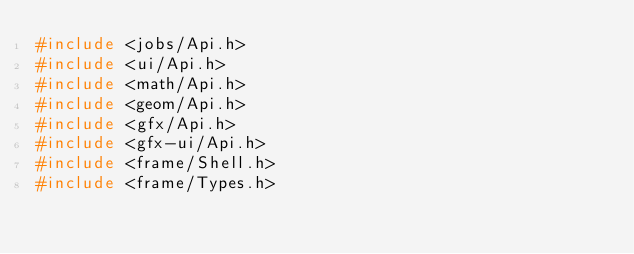<code> <loc_0><loc_0><loc_500><loc_500><_C_>#include <jobs/Api.h>
#include <ui/Api.h>
#include <math/Api.h>
#include <geom/Api.h>
#include <gfx/Api.h>
#include <gfx-ui/Api.h>
#include <frame/Shell.h>
#include <frame/Types.h>
</code> 